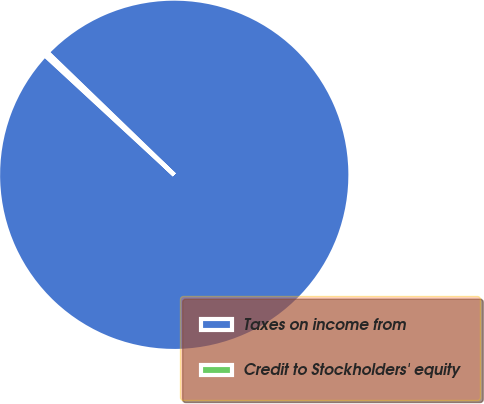Convert chart to OTSL. <chart><loc_0><loc_0><loc_500><loc_500><pie_chart><fcel>Taxes on income from<fcel>Credit to Stockholders' equity<nl><fcel>99.65%<fcel>0.35%<nl></chart> 